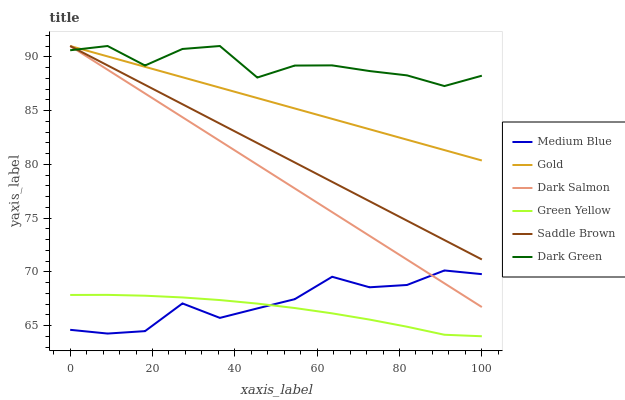Does Medium Blue have the minimum area under the curve?
Answer yes or no. No. Does Medium Blue have the maximum area under the curve?
Answer yes or no. No. Is Medium Blue the smoothest?
Answer yes or no. No. Is Medium Blue the roughest?
Answer yes or no. No. Does Medium Blue have the lowest value?
Answer yes or no. No. Does Medium Blue have the highest value?
Answer yes or no. No. Is Green Yellow less than Dark Salmon?
Answer yes or no. Yes. Is Gold greater than Green Yellow?
Answer yes or no. Yes. Does Green Yellow intersect Dark Salmon?
Answer yes or no. No. 